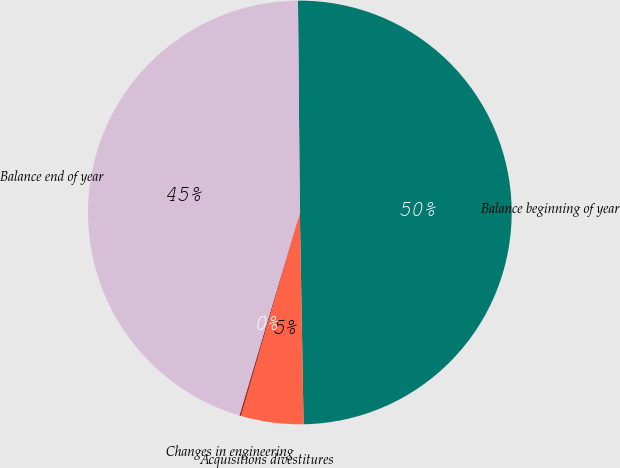<chart> <loc_0><loc_0><loc_500><loc_500><pie_chart><fcel>Balance beginning of year<fcel>Acquisitions divestitures<fcel>Changes in engineering<fcel>Balance end of year<nl><fcel>49.86%<fcel>4.75%<fcel>0.14%<fcel>45.25%<nl></chart> 